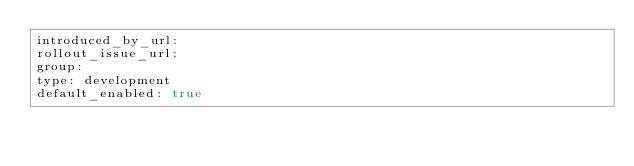Convert code to text. <code><loc_0><loc_0><loc_500><loc_500><_YAML_>introduced_by_url: 
rollout_issue_url: 
group: 
type: development
default_enabled: true
</code> 